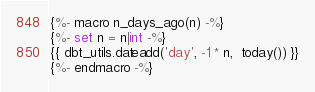<code> <loc_0><loc_0><loc_500><loc_500><_SQL_>{%- macro n_days_ago(n) -%}
{%- set n = n|int -%}
{{ dbt_utils.dateadd('day', -1 * n,  today()) }}
{%- endmacro -%}</code> 